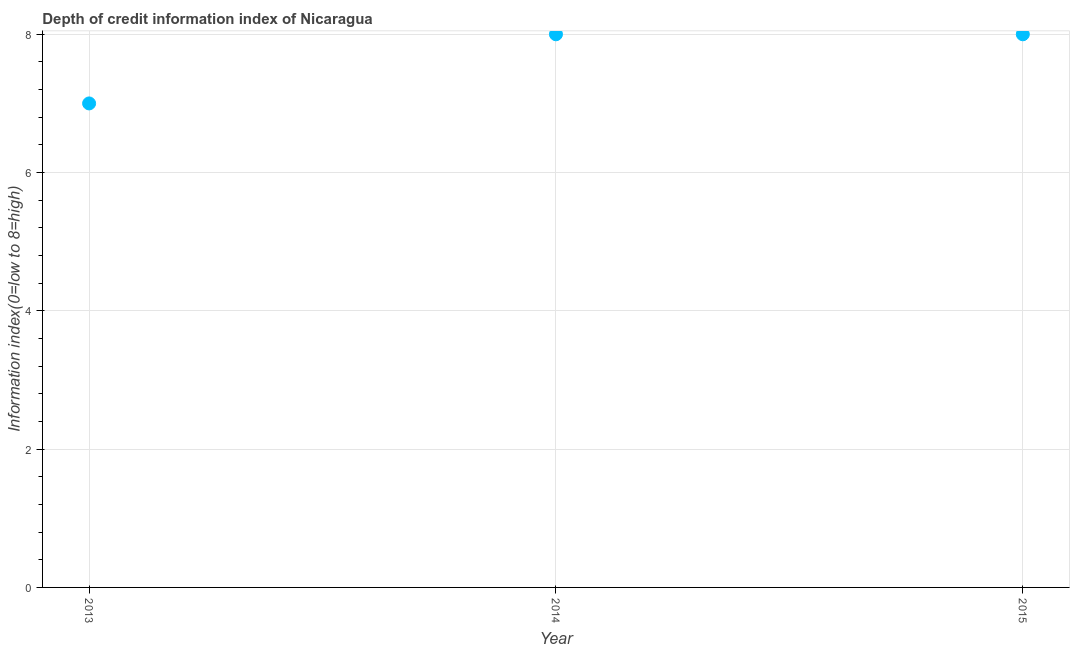What is the depth of credit information index in 2013?
Give a very brief answer. 7. Across all years, what is the maximum depth of credit information index?
Ensure brevity in your answer.  8. Across all years, what is the minimum depth of credit information index?
Provide a short and direct response. 7. In which year was the depth of credit information index minimum?
Your answer should be very brief. 2013. What is the sum of the depth of credit information index?
Offer a terse response. 23. What is the difference between the depth of credit information index in 2013 and 2014?
Your answer should be very brief. -1. What is the average depth of credit information index per year?
Ensure brevity in your answer.  7.67. What is the median depth of credit information index?
Provide a succinct answer. 8. In how many years, is the depth of credit information index greater than 3.6 ?
Make the answer very short. 3. What is the difference between the highest and the lowest depth of credit information index?
Keep it short and to the point. 1. How many dotlines are there?
Your response must be concise. 1. How many years are there in the graph?
Your answer should be compact. 3. What is the difference between two consecutive major ticks on the Y-axis?
Keep it short and to the point. 2. What is the title of the graph?
Make the answer very short. Depth of credit information index of Nicaragua. What is the label or title of the X-axis?
Ensure brevity in your answer.  Year. What is the label or title of the Y-axis?
Offer a very short reply. Information index(0=low to 8=high). What is the Information index(0=low to 8=high) in 2015?
Your answer should be very brief. 8. What is the difference between the Information index(0=low to 8=high) in 2013 and 2015?
Your response must be concise. -1. What is the difference between the Information index(0=low to 8=high) in 2014 and 2015?
Offer a terse response. 0. What is the ratio of the Information index(0=low to 8=high) in 2013 to that in 2014?
Keep it short and to the point. 0.88. What is the ratio of the Information index(0=low to 8=high) in 2013 to that in 2015?
Your answer should be compact. 0.88. 